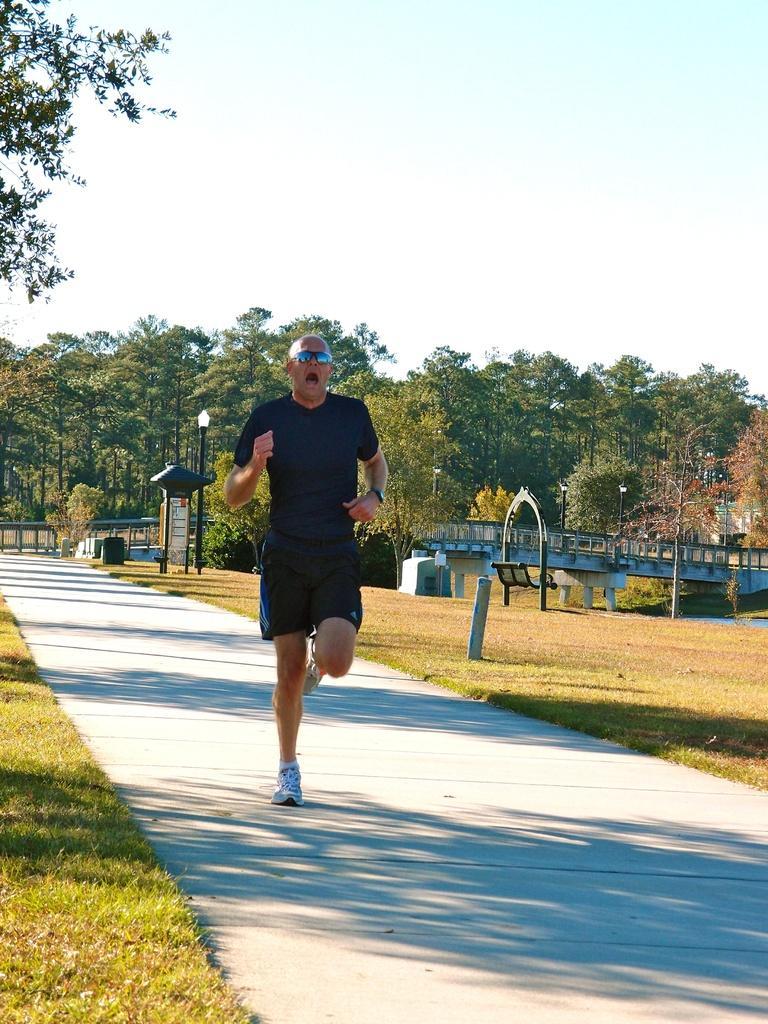Could you give a brief overview of what you see in this image? In this image we can see a man running on the floor. In the background there are sky with clouds, trees, bridge, bench on the ground, street poles, street lights and bins. 